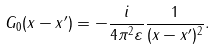<formula> <loc_0><loc_0><loc_500><loc_500>G _ { 0 } ( x - x ^ { \prime } ) = - \frac { i } { 4 \pi ^ { 2 } \varepsilon } \frac { 1 } { ( x - x ^ { \prime } ) ^ { 2 } } .</formula> 